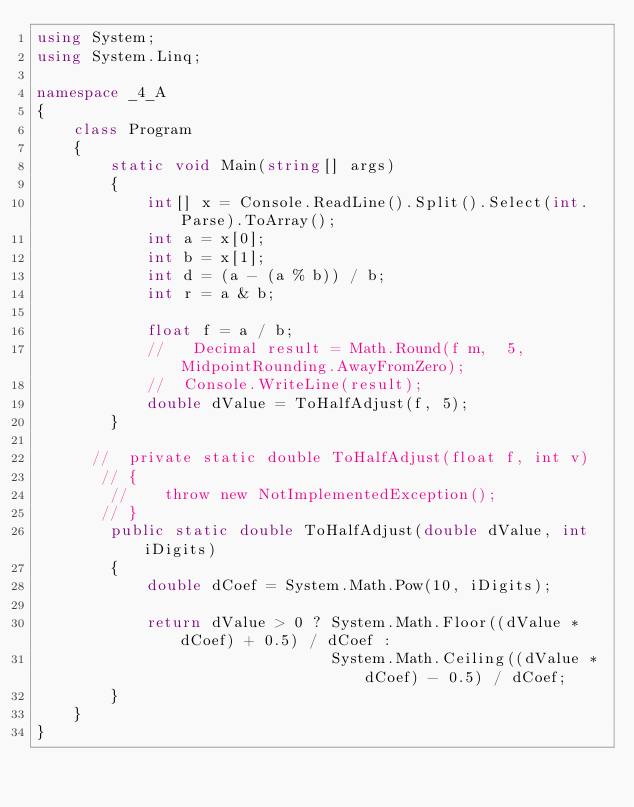Convert code to text. <code><loc_0><loc_0><loc_500><loc_500><_C#_>using System;
using System.Linq;

namespace _4_A
{
    class Program
    {
        static void Main(string[] args)
        {
            int[] x = Console.ReadLine().Split().Select(int.Parse).ToArray();
            int a = x[0];
            int b = x[1];
            int d = (a - (a % b)) / b;
            int r = a & b;
          
            float f = a / b;
            //   Decimal result = Math.Round(f m,  5, MidpointRounding.AwayFromZero);
            //  Console.WriteLine(result);
            double dValue = ToHalfAdjust(f, 5);
        }

      //  private static double ToHalfAdjust(float f, int v)
       // {
        //    throw new NotImplementedException();
       // }
        public static double ToHalfAdjust(double dValue, int iDigits)
        {
            double dCoef = System.Math.Pow(10, iDigits);

            return dValue > 0 ? System.Math.Floor((dValue * dCoef) + 0.5) / dCoef :
                                System.Math.Ceiling((dValue * dCoef) - 0.5) / dCoef;
        }
    }
}</code> 